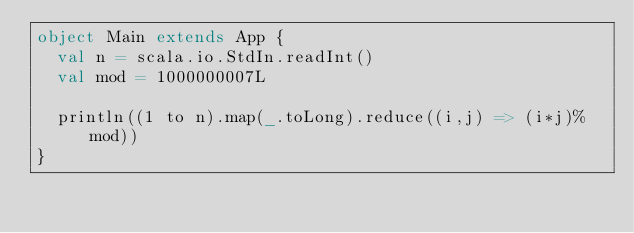Convert code to text. <code><loc_0><loc_0><loc_500><loc_500><_Scala_>object Main extends App {
  val n = scala.io.StdIn.readInt()
  val mod = 1000000007L

  println((1 to n).map(_.toLong).reduce((i,j) => (i*j)%mod))
}</code> 